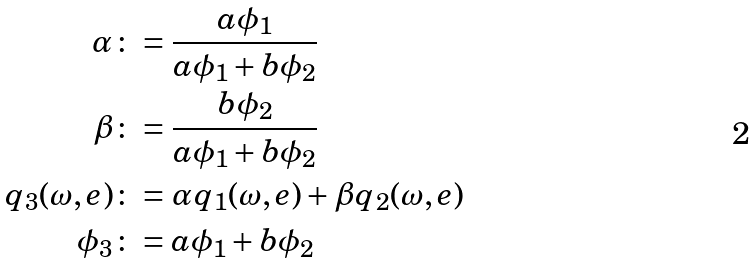<formula> <loc_0><loc_0><loc_500><loc_500>\alpha & \colon = \frac { a \phi _ { 1 } } { a \phi _ { 1 } + b \phi _ { 2 } } \\ \beta & \colon = \frac { b \phi _ { 2 } } { a \phi _ { 1 } + b \phi _ { 2 } } \\ q _ { 3 } ( \omega , e ) & \colon = \alpha q _ { 1 } ( \omega , e ) + \beta q _ { 2 } ( \omega , e ) \\ \phi _ { 3 } & \colon = a \phi _ { 1 } + b \phi _ { 2 } \\</formula> 